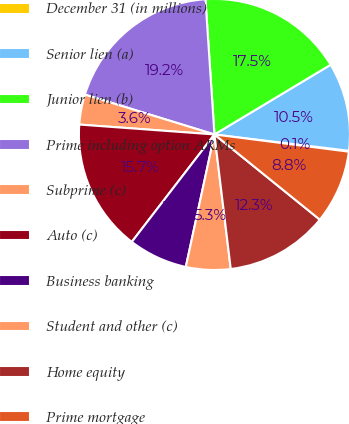Convert chart to OTSL. <chart><loc_0><loc_0><loc_500><loc_500><pie_chart><fcel>December 31 (in millions)<fcel>Senior lien (a)<fcel>Junior lien (b)<fcel>Prime including option ARMs<fcel>Subprime (c)<fcel>Auto (c)<fcel>Business banking<fcel>Student and other (c)<fcel>Home equity<fcel>Prime mortgage<nl><fcel>0.11%<fcel>10.52%<fcel>17.46%<fcel>19.2%<fcel>3.58%<fcel>15.73%<fcel>7.05%<fcel>5.31%<fcel>12.26%<fcel>8.79%<nl></chart> 